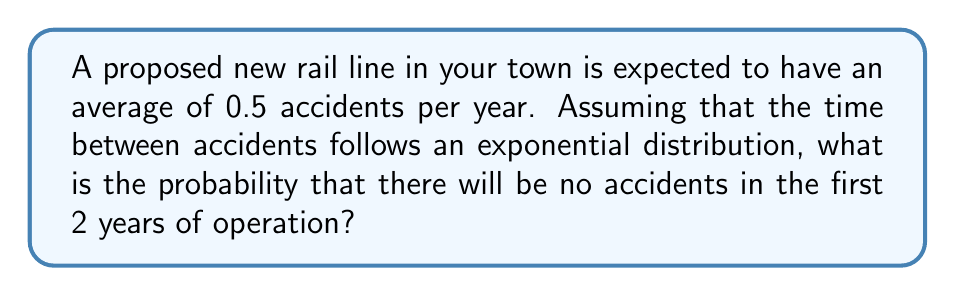Could you help me with this problem? Let's approach this step-by-step:

1) The exponential distribution is often used to model the time between events in a Poisson process. In this case, we're modeling the time between rail accidents.

2) The probability density function of an exponential distribution is:

   $$f(x) = \lambda e^{-\lambda x}$$

   where $\lambda$ is the rate parameter.

3) In this problem, we're given the average number of accidents per year, which is the rate parameter $\lambda = 0.5$.

4) We want to find the probability of no accidents in 2 years. This is equivalent to finding the probability that the time until the first accident is greater than 2 years.

5) For an exponential distribution, this probability is given by:

   $$P(X > t) = e^{-\lambda t}$$

6) Substituting our values ($\lambda = 0.5$ and $t = 2$):

   $$P(X > 2) = e^{-0.5 * 2} = e^{-1}$$

7) Calculate this value:

   $$e^{-1} \approx 0.3679$$

Therefore, the probability of no accidents in the first 2 years is approximately 0.3679 or about 36.79%.
Answer: $e^{-1} \approx 0.3679$ or 36.79% 